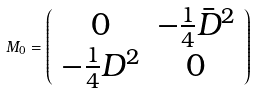<formula> <loc_0><loc_0><loc_500><loc_500>M _ { 0 } = \left ( \begin{array} { c c } 0 & - \frac { 1 } { 4 } \bar { D } ^ { 2 } \\ - \frac { 1 } { 4 } D ^ { 2 } & 0 \end{array} \right )</formula> 